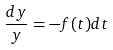<formula> <loc_0><loc_0><loc_500><loc_500>\frac { d y } { y } = - f ( t ) d t</formula> 